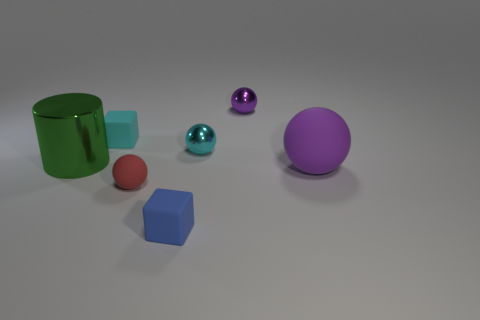Subtract all large matte spheres. How many spheres are left? 3 Subtract all red spheres. How many spheres are left? 3 Subtract 1 balls. How many balls are left? 3 Add 2 cyan blocks. How many objects exist? 9 Subtract all brown balls. Subtract all brown cubes. How many balls are left? 4 Subtract all cylinders. How many objects are left? 6 Add 7 cyan blocks. How many cyan blocks are left? 8 Add 3 tiny cyan metal objects. How many tiny cyan metal objects exist? 4 Subtract 0 blue balls. How many objects are left? 7 Subtract all matte cubes. Subtract all yellow rubber cubes. How many objects are left? 5 